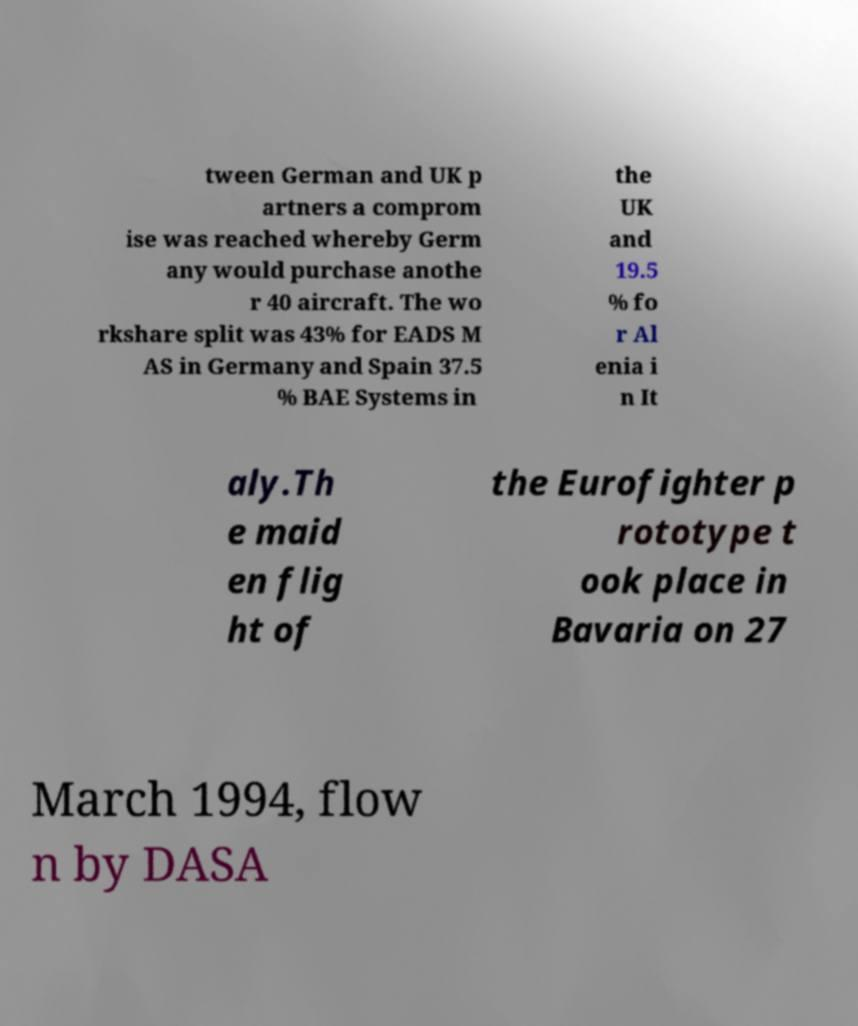I need the written content from this picture converted into text. Can you do that? tween German and UK p artners a comprom ise was reached whereby Germ any would purchase anothe r 40 aircraft. The wo rkshare split was 43% for EADS M AS in Germany and Spain 37.5 % BAE Systems in the UK and 19.5 % fo r Al enia i n It aly.Th e maid en flig ht of the Eurofighter p rototype t ook place in Bavaria on 27 March 1994, flow n by DASA 